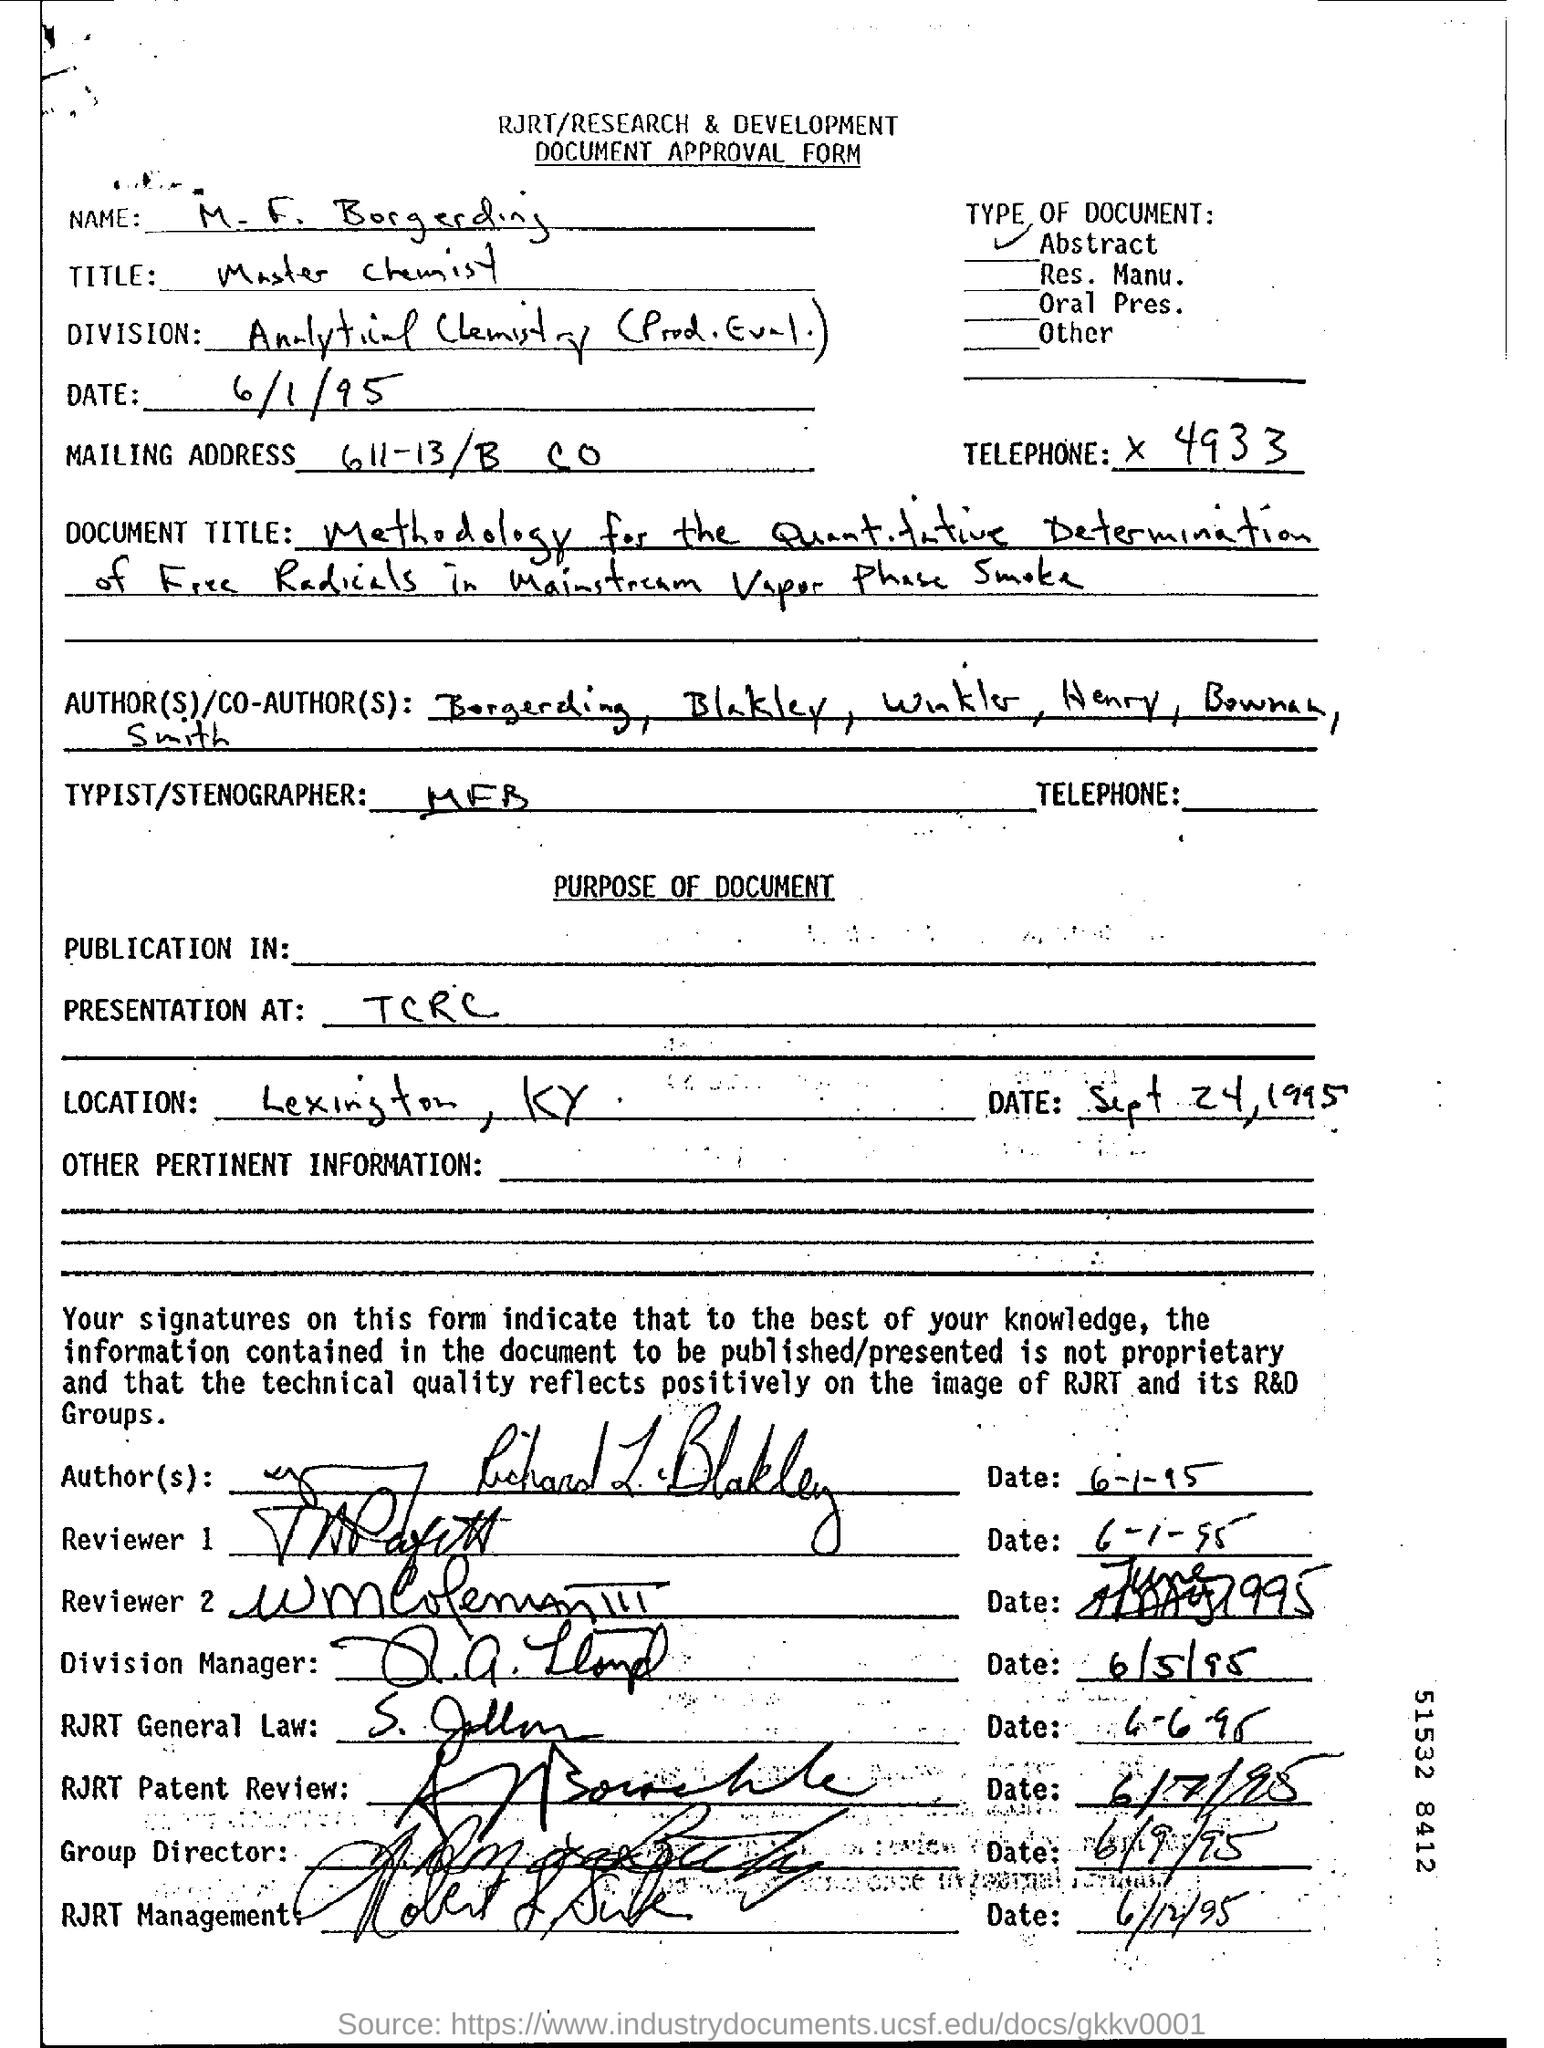What is the Mailing Address?
Your answer should be very brief. 611-13/B CO. What is the telephone number?
Make the answer very short. X 4933. What is the title of the person mentioned in the form?
Offer a terse response. Master Chemist. 